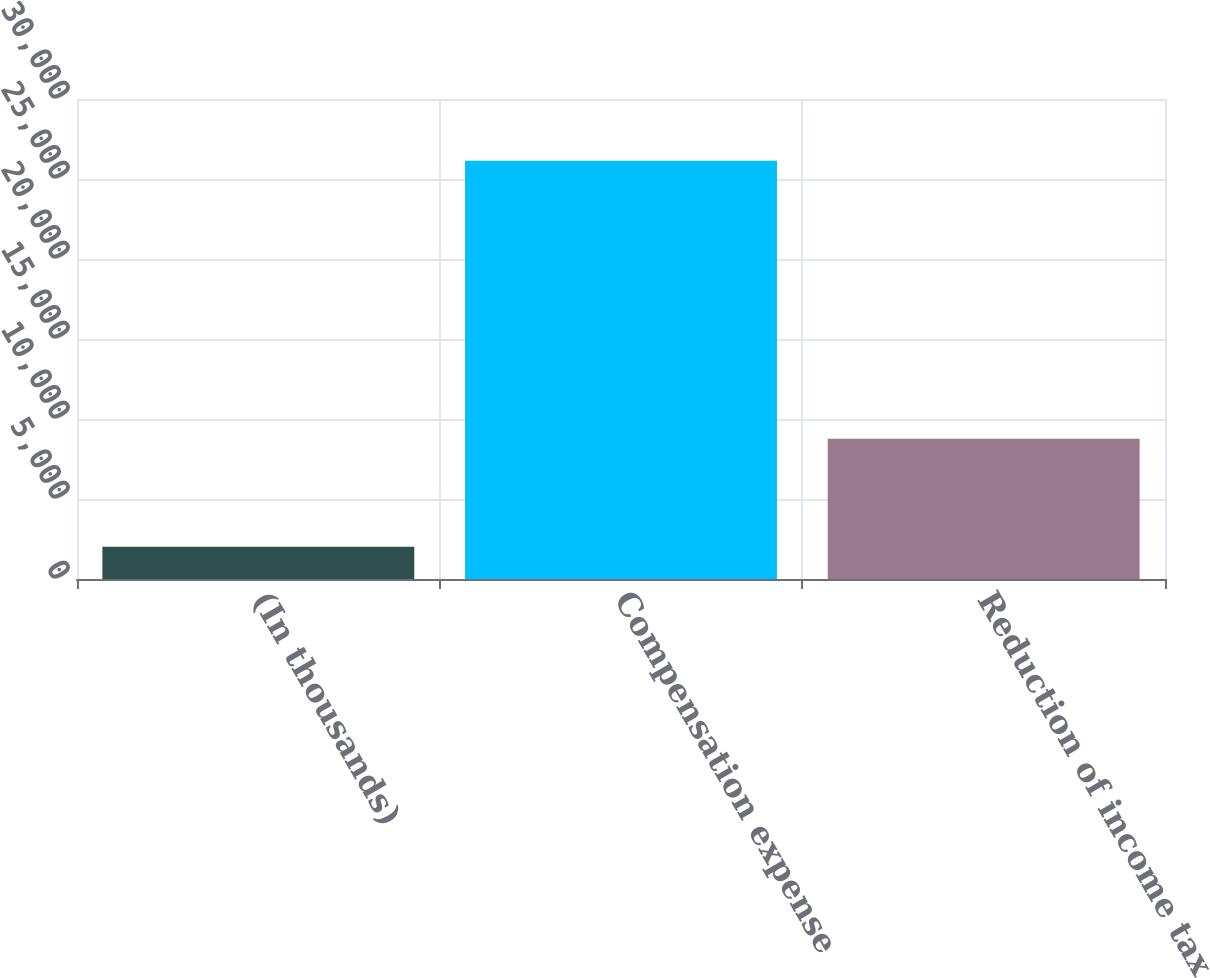Convert chart. <chart><loc_0><loc_0><loc_500><loc_500><bar_chart><fcel>(In thousands)<fcel>Compensation expense<fcel>Reduction of income tax<nl><fcel>2016<fcel>26144<fcel>8762<nl></chart> 